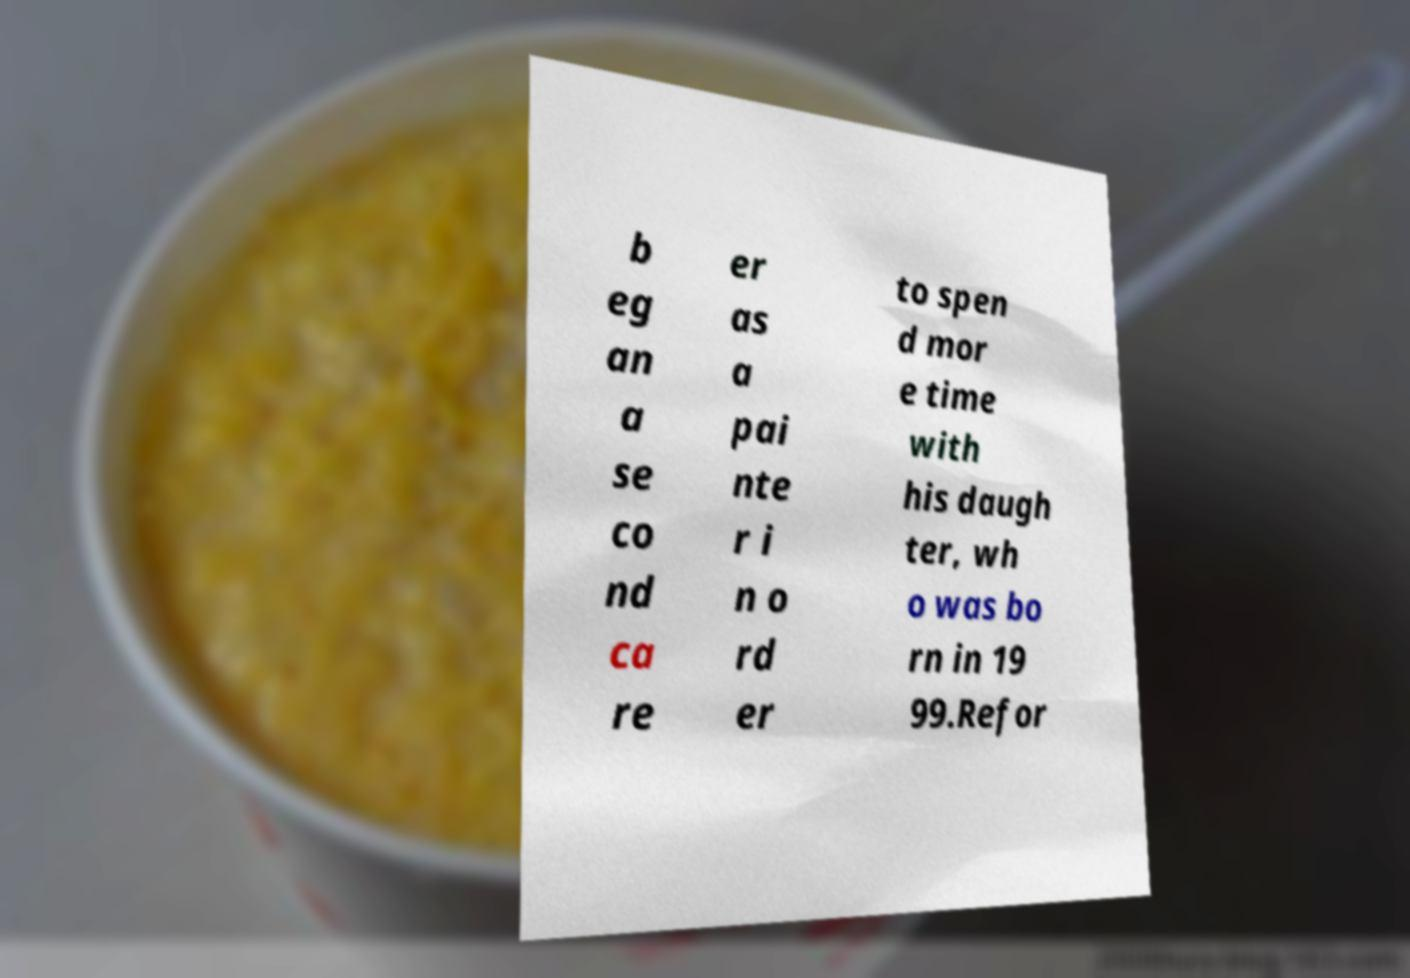Could you assist in decoding the text presented in this image and type it out clearly? b eg an a se co nd ca re er as a pai nte r i n o rd er to spen d mor e time with his daugh ter, wh o was bo rn in 19 99.Refor 